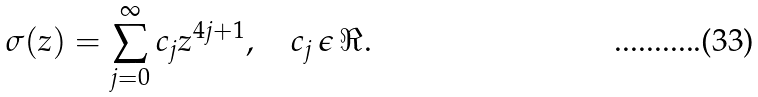<formula> <loc_0><loc_0><loc_500><loc_500>\sigma ( z ) = \sum _ { j = 0 } ^ { \infty } { c } _ { j } z ^ { 4 j + 1 } , \quad c _ { j } \, \epsilon \, \Re .</formula> 